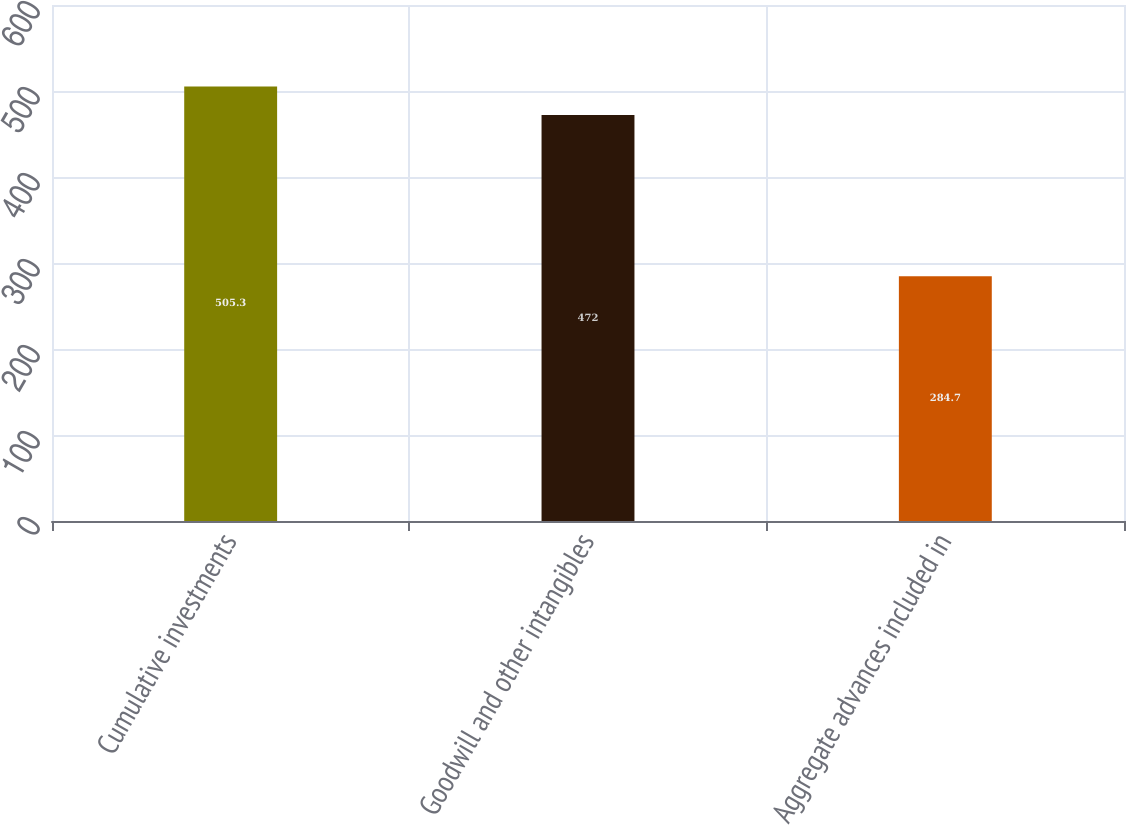Convert chart to OTSL. <chart><loc_0><loc_0><loc_500><loc_500><bar_chart><fcel>Cumulative investments<fcel>Goodwill and other intangibles<fcel>Aggregate advances included in<nl><fcel>505.3<fcel>472<fcel>284.7<nl></chart> 